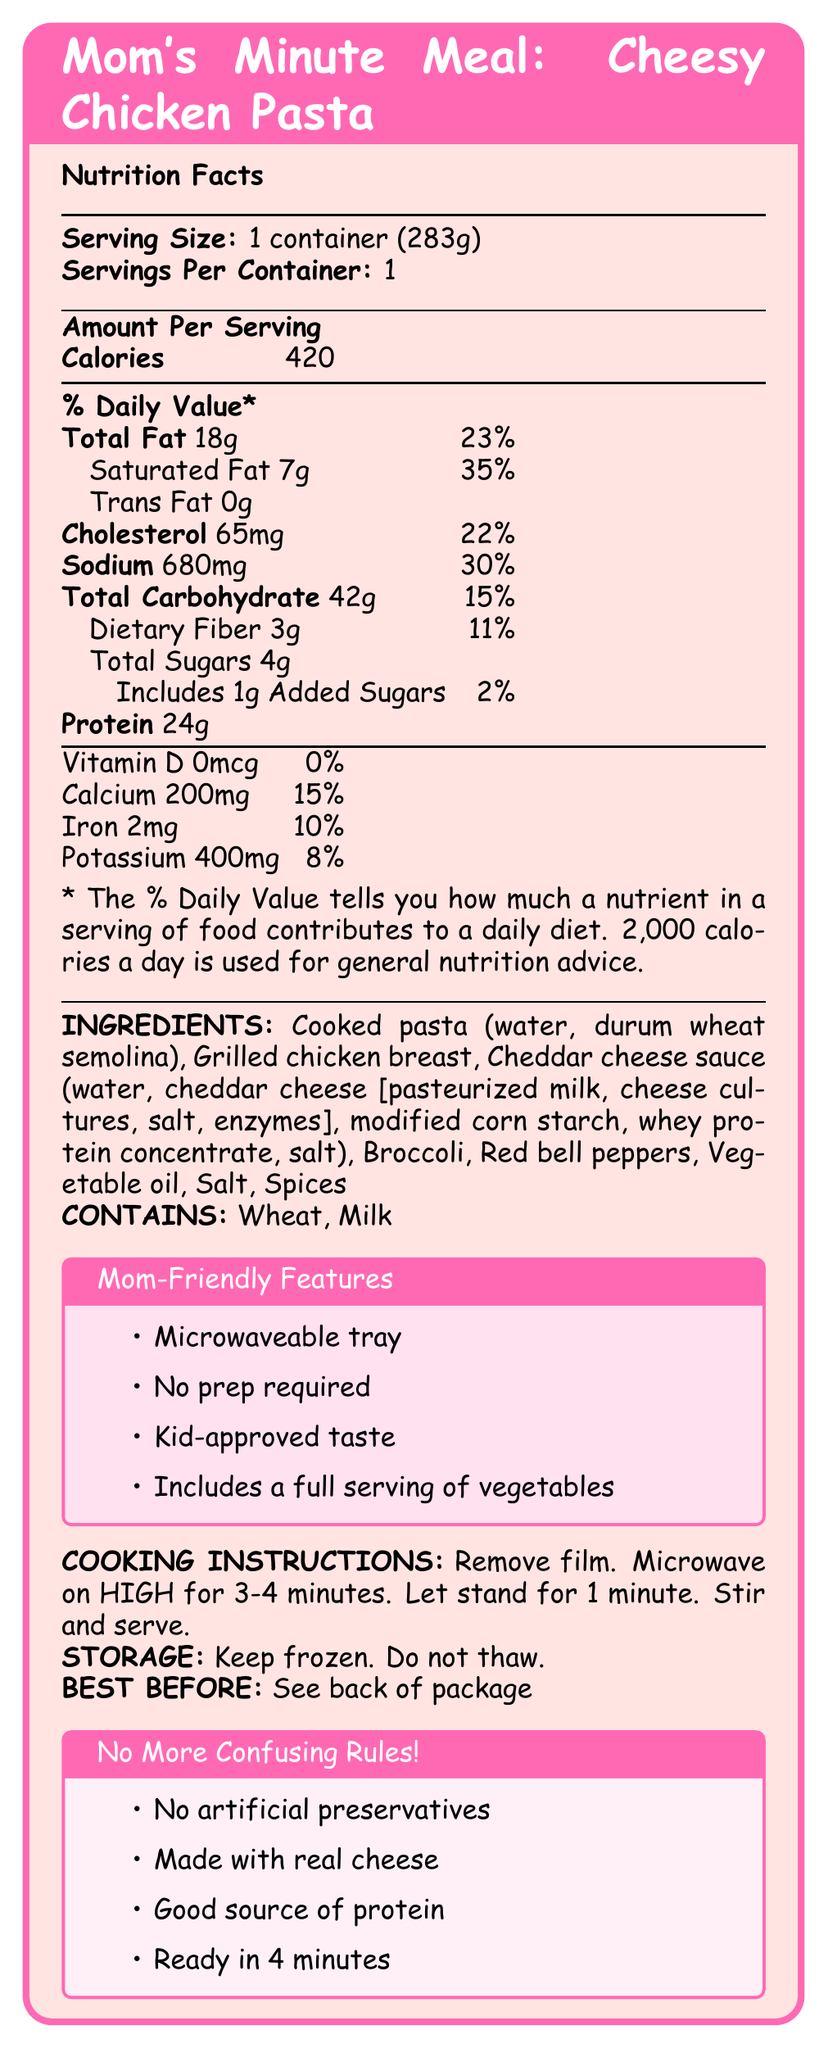what is the serving size? The document specifies that the serving size is "1 container (283g)".
Answer: 1 container (283g) how many calories are there per serving? The document indicates that each serving contains 420 calories.
Answer: 420 what is the amount of total fat in this meal? The document lists the total fat content as 18g.
Answer: 18g what percentage of the daily value for sodium does this meal contain? The document shows that this meal provides 30% of the daily value for sodium.
Answer: 30% which allergens does this meal contain? The document states that the meal contains wheat and milk.
Answer: Wheat, Milk how much protein does this meal have? A. 10g B. 24g C. 35g D. 50g The document specifies that the meal contains 24g of protein.
Answer: B. 24g what is the amount of calcium in this meal? A. 100mg B. 200mg C. 400mg D. 0mcg The document states that there are 200mg of calcium in the meal.
Answer: B. 200mg is there any vitamin D in this meal? The document indicates that the meal contains 0mcg of vitamin D, which means it has no vitamin D.
Answer: No does this product contain any artificial preservatives? The document claims that the product has "No artificial preservatives".
Answer: No what are the main features highlighted for busy moms? The document highlights features such as a microwaveable tray, no prep required, kid-approved taste, and includes a full serving of vegetables for busy moms.
Answer: Microwaveable tray, No prep required, Kid-approved taste, Includes a full serving of vegetables what is the total amount of sugars in this meal? The document states that the total sugars amount is 4g.
Answer: 4g is this meal considered a good source of protein? The document claims that the meal is a "Good source of protein".
Answer: Yes is the product meant to be stored at room temperature? The document instructs to "Keep frozen. Do not thaw," indicating it should not be stored at room temperature.
Answer: No what is the main idea of this document? The document is primarily focused on providing detailed nutritional information, ingredients, allergens, and user-friendly features for the product "Mom's Minute Meal: Cheesy Chicken Pasta".
Answer: The document presents the Nutrition Facts for "Mom's Minute Meal: Cheesy Chicken Pasta", highlighting its nutritional content, ingredients, allergens, cooking instructions, and features appealing to busy moms. how many servings are in each container? The document specifies that there is 1 serving per container.
Answer: 1 how much saturated fat does this meal contain? The document lists the saturated fat content as 7g.
Answer: 7g how much of the daily value for dietary fiber does this meal provide? The document indicates that the meal provides 11% of the daily value for dietary fiber.
Answer: 11% what percentage of the daily value for iron is in this meal? The document shows that the meal provides 10% of the daily value for iron.
Answer: 10% how long should the meal be microwaved? The document instructs to microwave the meal on HIGH for 3-4 minutes.
Answer: 3-4 minutes on HIGH does this document provide the best before date of the meal? The document only states "See back of package" for the best before date. This information is not provided within the document itself.
Answer: I don't know 